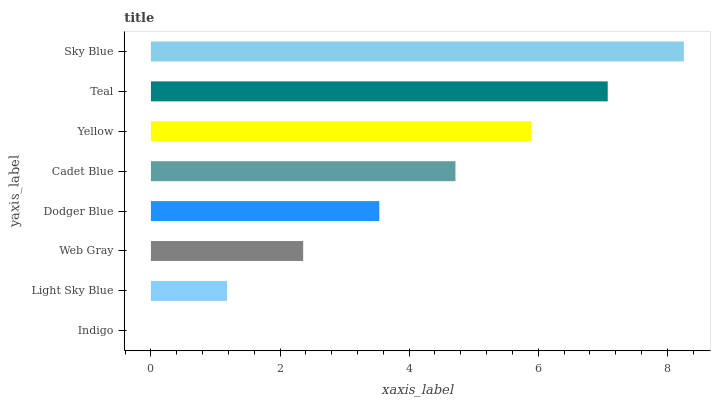Is Indigo the minimum?
Answer yes or no. Yes. Is Sky Blue the maximum?
Answer yes or no. Yes. Is Light Sky Blue the minimum?
Answer yes or no. No. Is Light Sky Blue the maximum?
Answer yes or no. No. Is Light Sky Blue greater than Indigo?
Answer yes or no. Yes. Is Indigo less than Light Sky Blue?
Answer yes or no. Yes. Is Indigo greater than Light Sky Blue?
Answer yes or no. No. Is Light Sky Blue less than Indigo?
Answer yes or no. No. Is Cadet Blue the high median?
Answer yes or no. Yes. Is Dodger Blue the low median?
Answer yes or no. Yes. Is Sky Blue the high median?
Answer yes or no. No. Is Yellow the low median?
Answer yes or no. No. 